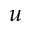<formula> <loc_0><loc_0><loc_500><loc_500>u</formula> 